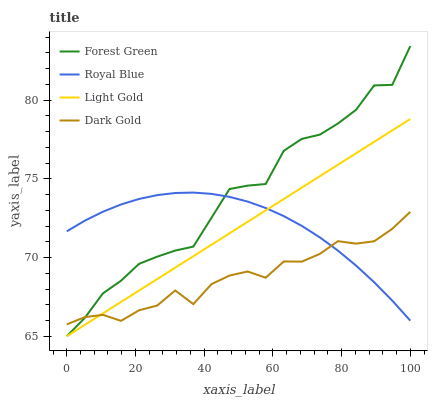Does Dark Gold have the minimum area under the curve?
Answer yes or no. Yes. Does Forest Green have the maximum area under the curve?
Answer yes or no. Yes. Does Light Gold have the minimum area under the curve?
Answer yes or no. No. Does Light Gold have the maximum area under the curve?
Answer yes or no. No. Is Light Gold the smoothest?
Answer yes or no. Yes. Is Forest Green the roughest?
Answer yes or no. Yes. Is Forest Green the smoothest?
Answer yes or no. No. Is Light Gold the roughest?
Answer yes or no. No. Does Forest Green have the lowest value?
Answer yes or no. Yes. Does Dark Gold have the lowest value?
Answer yes or no. No. Does Forest Green have the highest value?
Answer yes or no. Yes. Does Light Gold have the highest value?
Answer yes or no. No. Does Light Gold intersect Forest Green?
Answer yes or no. Yes. Is Light Gold less than Forest Green?
Answer yes or no. No. Is Light Gold greater than Forest Green?
Answer yes or no. No. 